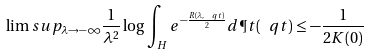<formula> <loc_0><loc_0><loc_500><loc_500>\lim s u p _ { \lambda \rightarrow - \infty } \frac { 1 } { \lambda ^ { 2 } } \log \int _ { H } e ^ { - \frac { R ( \lambda , \ q t ) } { 2 } } d \P t ( \ q t ) \leq - \frac { 1 } { 2 K ( 0 ) }</formula> 